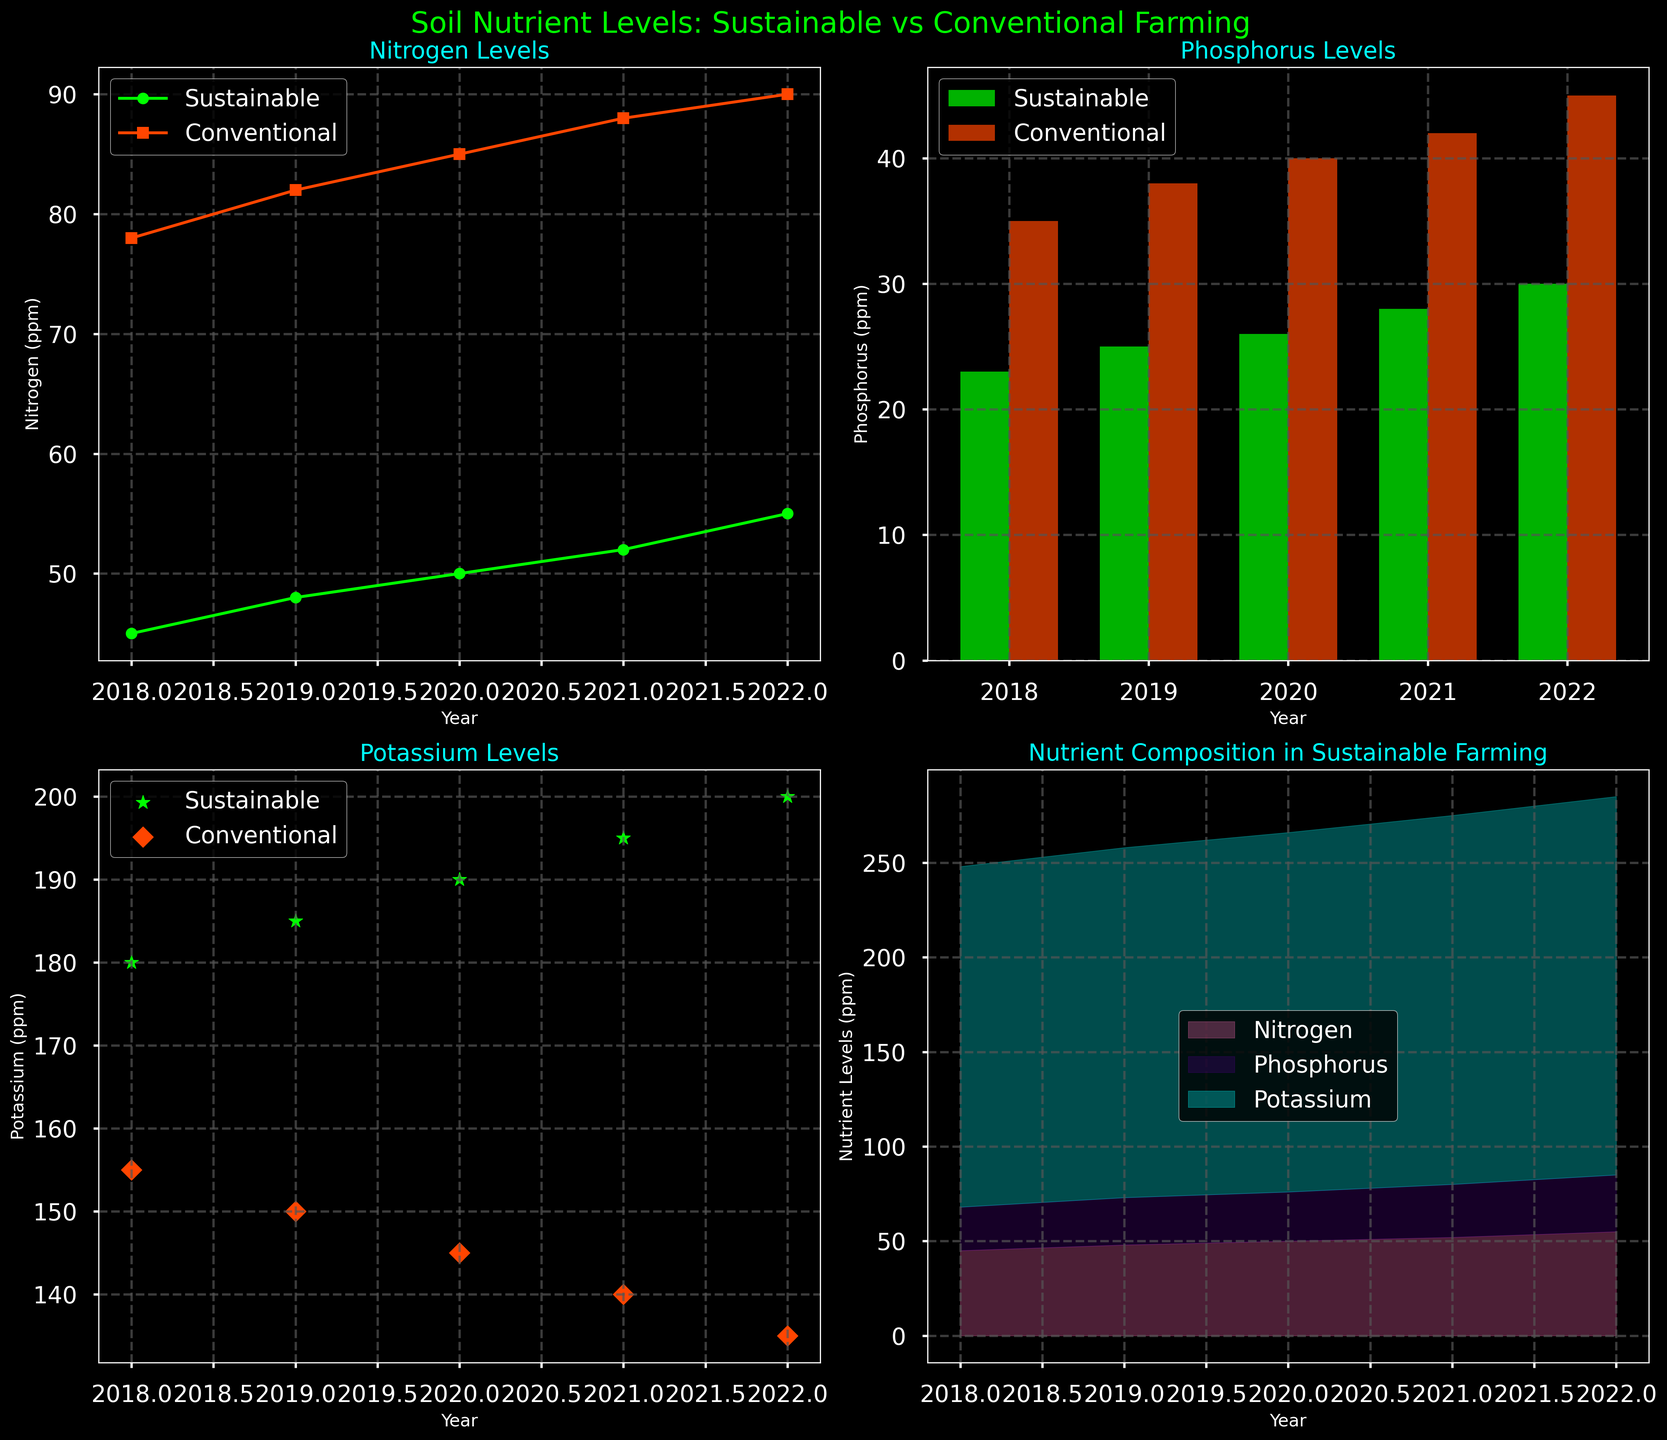What is the highest nitrogen level recorded for conventional farming? To find the highest nitrogen level for conventional farming, look at the nitrogen levels for conventional farming across all years. The highest value is 90 ppm, recorded in 2022.
Answer: 90 ppm How does the phosphorus level of sustainable farming in 2020 compare to conventional farming in the same year? Look at the phosphorus levels in 2020 for both types of farming. Sustainable farming has a phosphorus level of 26 ppm, and conventional farming has 40 ppm. Subtract 26 from 40 to get the difference.
Answer: 14 ppm lower Which farming type shows a consistent increase in potassium levels over the years? Check the trend for potassium levels in both farming types from 2018 to 2022. Sustainable farming shows a consistent increase each year, whereas conventional farming shows a decrease.
Answer: Sustainable farming What is the combined nitrogen level for both farming types in 2019? Add the nitrogen levels for both sustainable and conventional farming in 2019. For sustainable farming, it's 48 ppm, and for conventional farming, it's 82 ppm. So, 48 + 82 = 130 ppm.
Answer: 130 ppm How does the total nutrient composition in sustainable farming change from 2018 to 2022? Look at the stacked area plot for sustainable farming and compare the filled areas representing nitrogen, phosphorus, and potassium from 2018 to 2022. There is a visible increase in the filled area for each nutrient, indicating a rise in total nutrient levels.
Answer: Increases What pattern do you observe in the phosphorus levels between sustainable and conventional farming over the years? By looking at the bar plots, you can see that phosphorus levels for both farming types increase over the years. Conventional farming always has higher phosphorus levels than sustainable farming.
Answer: Increasing, with conventional always higher In terms of nitrogen levels, which year shows the smallest difference between sustainable and conventional farming? Check the line plot and calculate the difference in nitrogen levels for each year. The smallest difference is in 2022, where sustainable farming has 55 ppm and conventional farming has 90 ppm, leading to a difference of 35 ppm.
Answer: 2022 What is the average potassium level for sustainable farming over the five years shown? Sum the potassium levels for sustainable farming from 2018 to 2022 and divide by the number of years. The levels are 180, 185, 190, 195, and 200 ppm. Sum = 950 ppm, and average = 950 / 5 = 190 ppm.
Answer: 190 ppm 